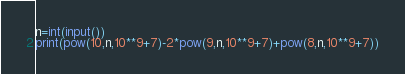<code> <loc_0><loc_0><loc_500><loc_500><_Python_>n=int(input())
print(pow(10,n,10**9+7)-2*pow(9,n,10**9+7)+pow(8,n,10**9+7))</code> 